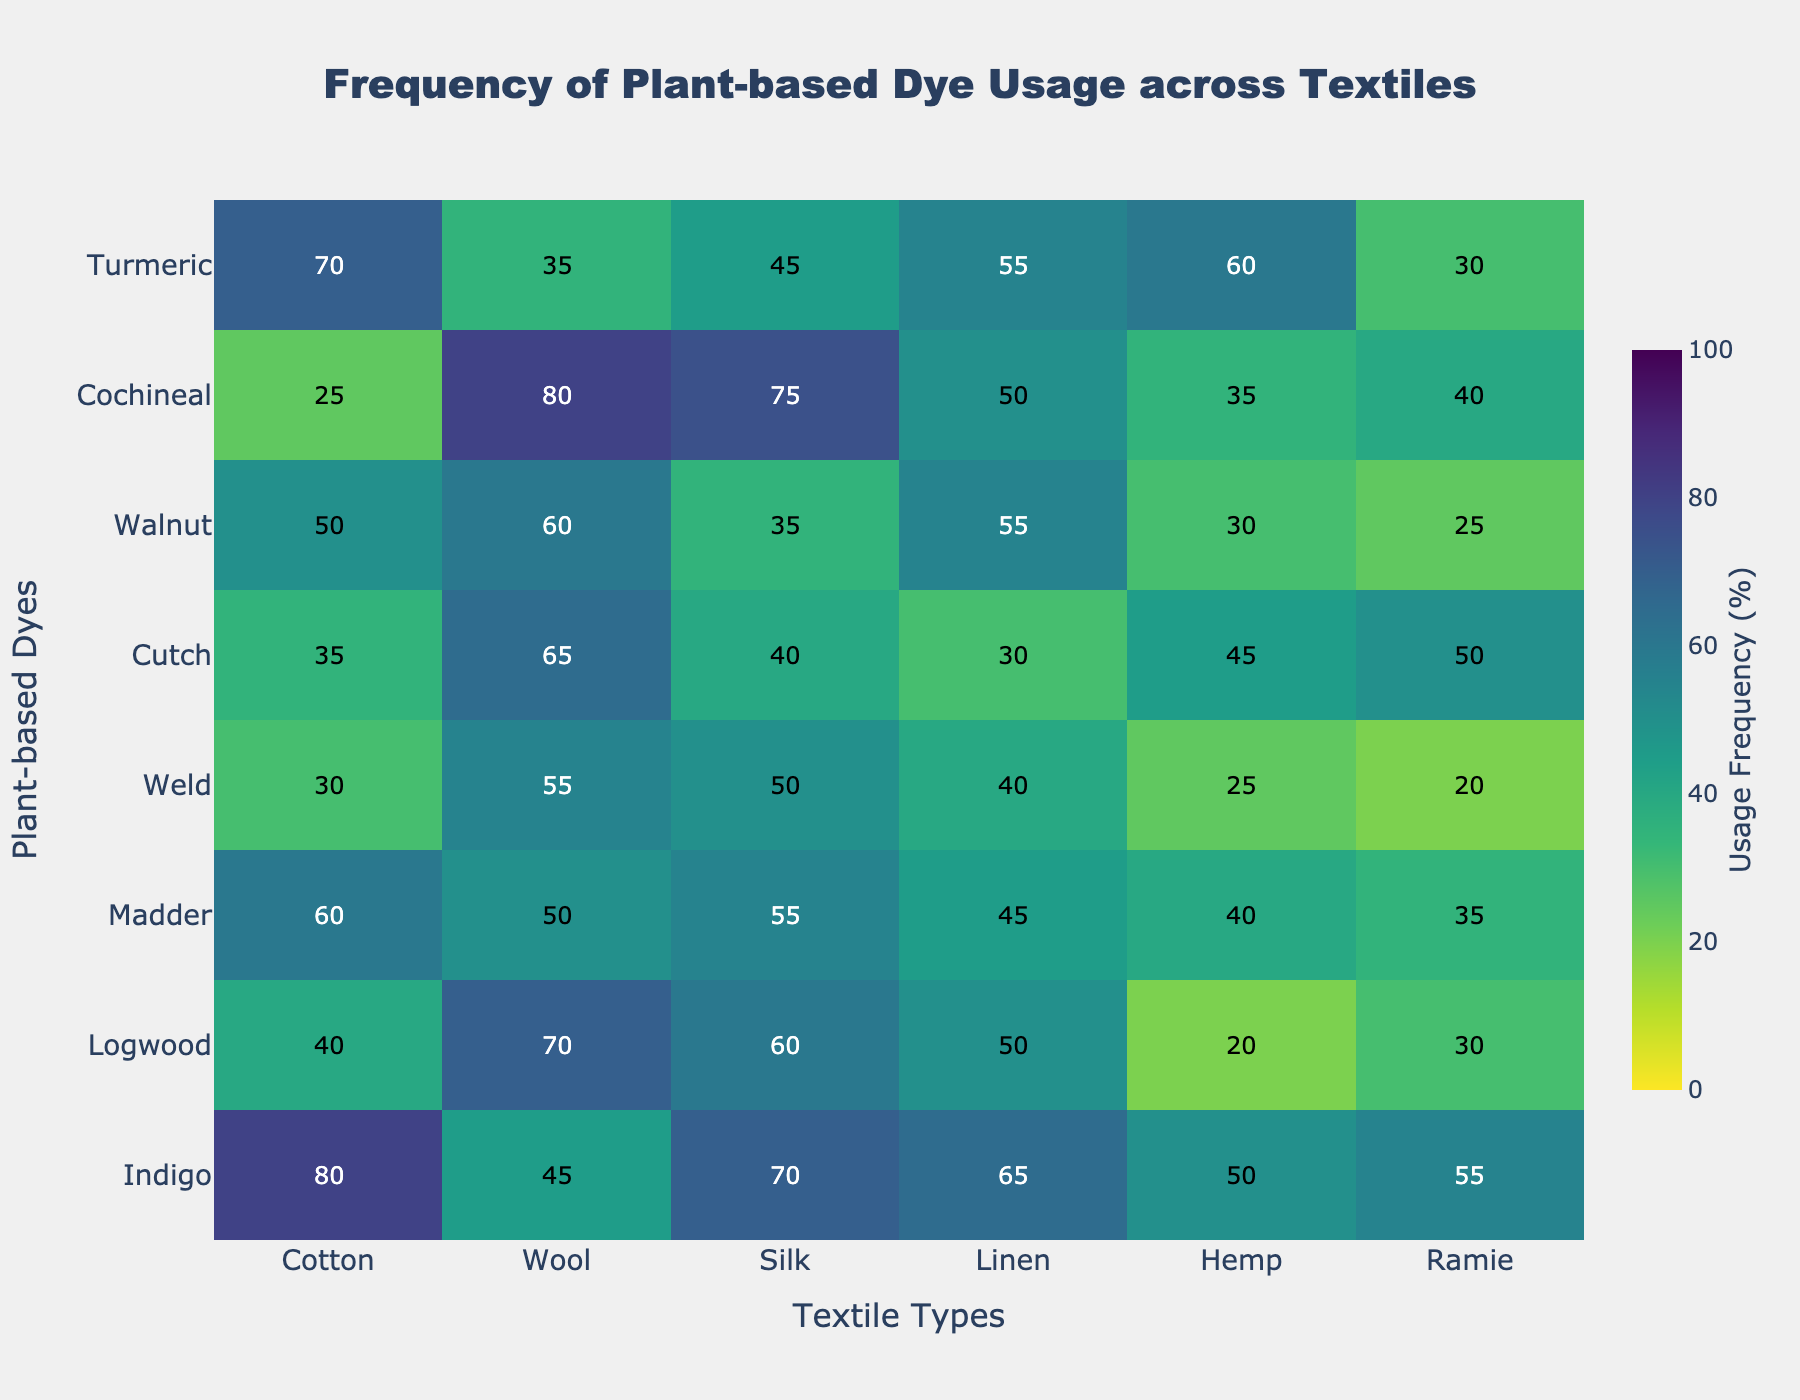What's the title of the heatmap? The title of the heatmap is prominently displayed at the top. It reads 'Frequency of Plant-based Dye Usage across Textiles'.
Answer: Frequency of Plant-based Dye Usage across Textiles Which plant-based dye has the highest usage frequency on cotton? By looking at the intersection of the row for each dye and the column for cotton, we see that Indigo has the highest value.
Answer: Indigo What textile type has the lowest usage frequency for Cochineal dye? Inspect the row for Cochineal and compare the values. The column with the lowest value is 'Cotton' with a value of 25.
Answer: Cotton How many dye-textile combinations have a usage frequency above 50%? Count all the cells in the heatmap with values above 50%. There are 11 such combinations.
Answer: 11 Which dye has a more balanced usage frequency across all textile types, Indigo or Madder? Inspect the rows for Indigo and Madder. Variability in values for Madder is lower, ranging from 35 to 60, whereas for Indigo it ranges wider from 45 to 80.
Answer: Madder Which textile exhibits the highest overall frequency for plant-based dye usage? Sum the columns for each textile and compare. The 'Cotton' column has the highest sum, indicating it has the overall highest frequency of usage.
Answer: Cotton Between Cotton and Linen, which textile shows a greater variety in dye usage frequency? Calculate the range (difference between max and min) of values for Cotton and Linen columns. Cotton has a range of 55 (80 - 25), Linen has a range of 35 (65 - 30). Cotton has a greater variety.
Answer: Cotton What is the average usage frequency of Turmeric dye across all textile types? Add the values for Turmeric across all textiles (70+35+45+55+60+30) and divide by the number of textile types (6). The sum is 295 and the average is 295/6 = 49.2
Answer: 49.2 Which dye is least frequently used on Ramie textile? By inspecting the Ramie column, Logwood has the lowest usage frequency of 30.
Answer: Logwood 